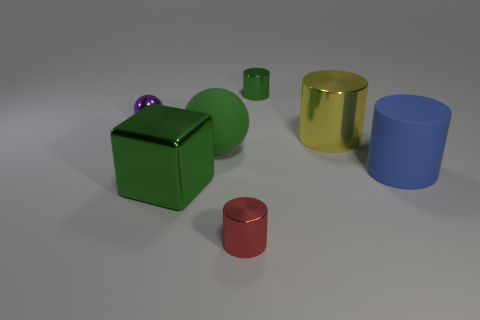Subtract all tiny green cylinders. How many cylinders are left? 3 Subtract all red cylinders. How many cylinders are left? 3 Add 2 green spheres. How many objects exist? 9 Subtract all cylinders. How many objects are left? 3 Add 7 small things. How many small things are left? 10 Add 7 green cylinders. How many green cylinders exist? 8 Subtract 1 red cylinders. How many objects are left? 6 Subtract all brown cylinders. Subtract all blue blocks. How many cylinders are left? 4 Subtract all tiny yellow metallic spheres. Subtract all small red things. How many objects are left? 6 